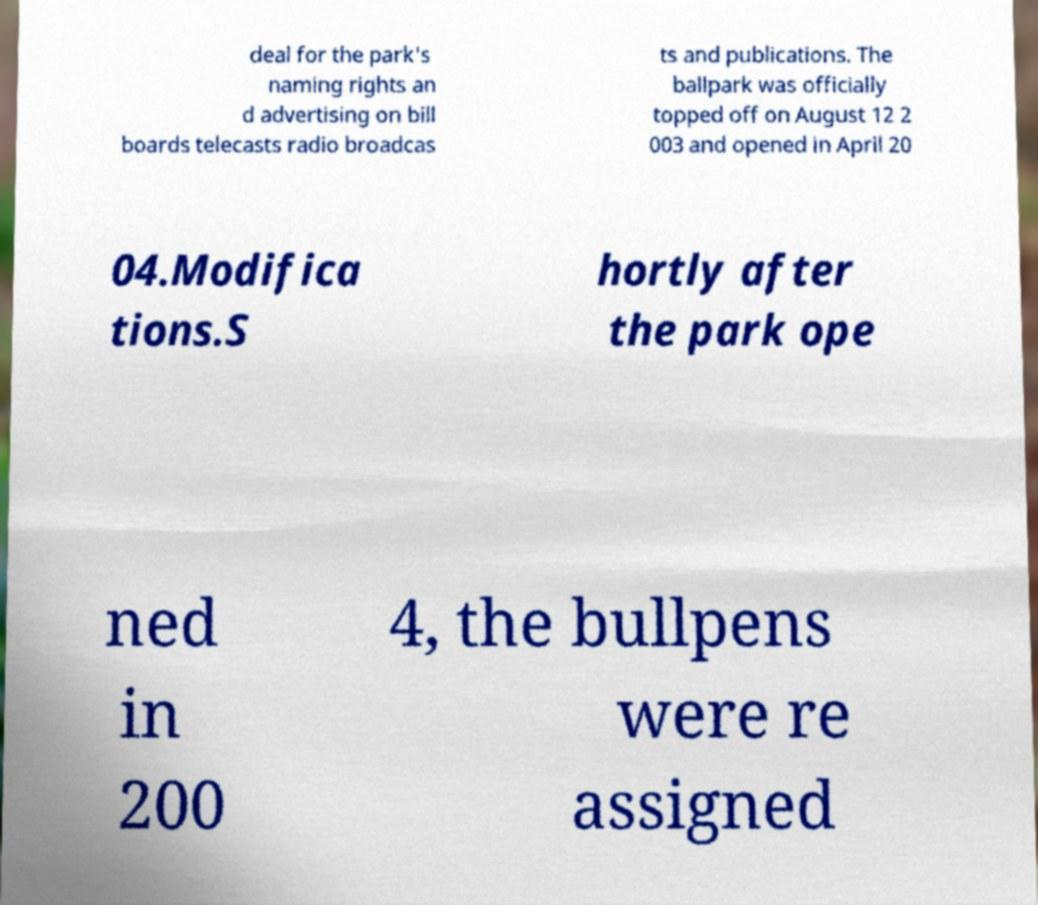Could you assist in decoding the text presented in this image and type it out clearly? deal for the park's naming rights an d advertising on bill boards telecasts radio broadcas ts and publications. The ballpark was officially topped off on August 12 2 003 and opened in April 20 04.Modifica tions.S hortly after the park ope ned in 200 4, the bullpens were re assigned 